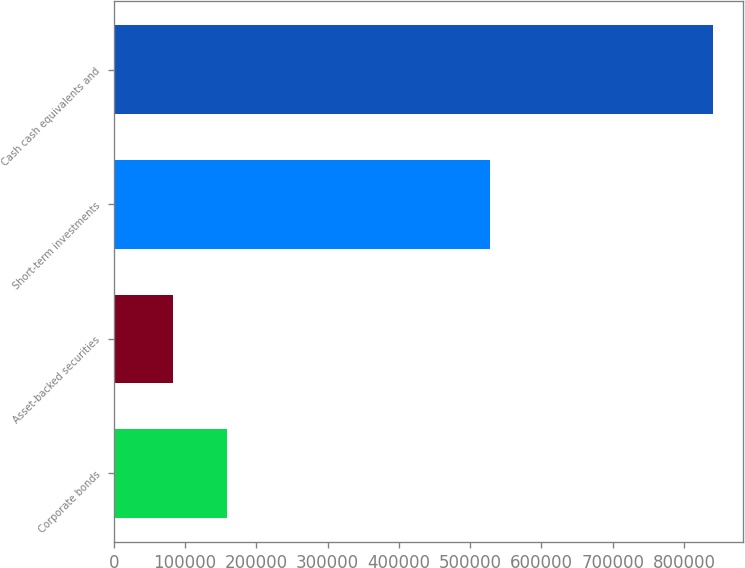<chart> <loc_0><loc_0><loc_500><loc_500><bar_chart><fcel>Corporate bonds<fcel>Asset-backed securities<fcel>Short-term investments<fcel>Cash cash equivalents and<nl><fcel>159311<fcel>83044<fcel>527256<fcel>840864<nl></chart> 